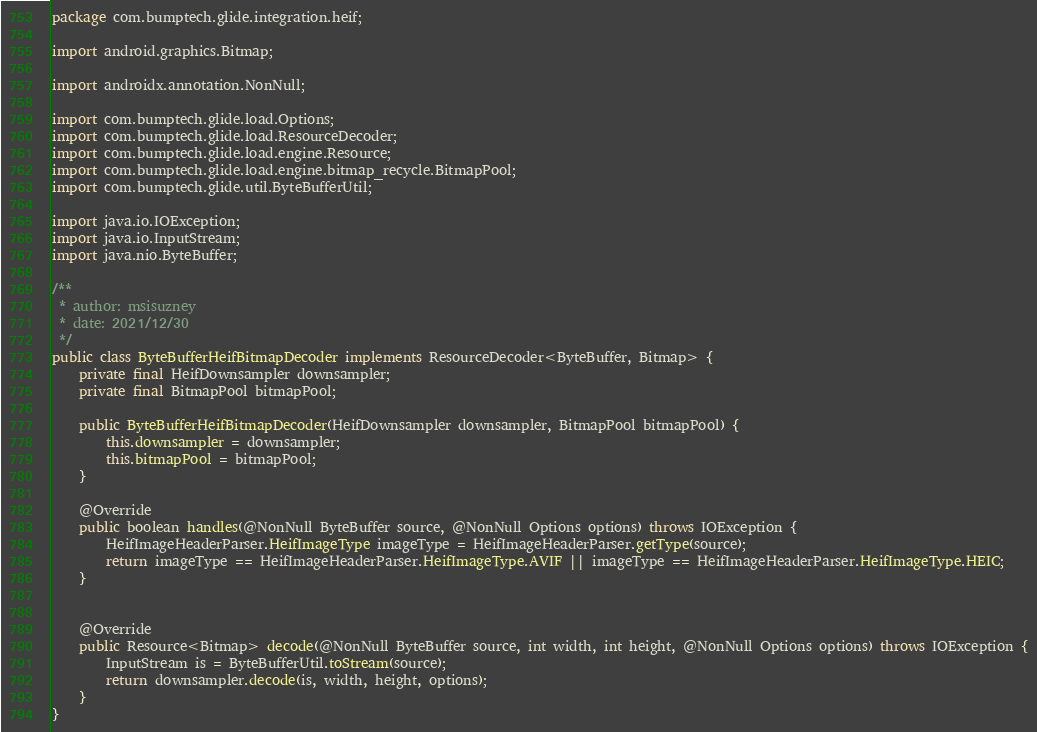Convert code to text. <code><loc_0><loc_0><loc_500><loc_500><_Java_>package com.bumptech.glide.integration.heif;

import android.graphics.Bitmap;

import androidx.annotation.NonNull;

import com.bumptech.glide.load.Options;
import com.bumptech.glide.load.ResourceDecoder;
import com.bumptech.glide.load.engine.Resource;
import com.bumptech.glide.load.engine.bitmap_recycle.BitmapPool;
import com.bumptech.glide.util.ByteBufferUtil;

import java.io.IOException;
import java.io.InputStream;
import java.nio.ByteBuffer;

/**
 * author: msisuzney
 * date: 2021/12/30
 */
public class ByteBufferHeifBitmapDecoder implements ResourceDecoder<ByteBuffer, Bitmap> {
    private final HeifDownsampler downsampler;
    private final BitmapPool bitmapPool;

    public ByteBufferHeifBitmapDecoder(HeifDownsampler downsampler, BitmapPool bitmapPool) {
        this.downsampler = downsampler;
        this.bitmapPool = bitmapPool;
    }

    @Override
    public boolean handles(@NonNull ByteBuffer source, @NonNull Options options) throws IOException {
        HeifImageHeaderParser.HeifImageType imageType = HeifImageHeaderParser.getType(source);
        return imageType == HeifImageHeaderParser.HeifImageType.AVIF || imageType == HeifImageHeaderParser.HeifImageType.HEIC;
    }


    @Override
    public Resource<Bitmap> decode(@NonNull ByteBuffer source, int width, int height, @NonNull Options options) throws IOException {
        InputStream is = ByteBufferUtil.toStream(source);
        return downsampler.decode(is, width, height, options);
    }
}
</code> 